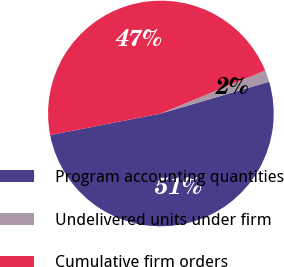<chart> <loc_0><loc_0><loc_500><loc_500><pie_chart><fcel>Program accounting quantities<fcel>Undelivered units under firm<fcel>Cumulative firm orders<nl><fcel>51.48%<fcel>1.68%<fcel>46.85%<nl></chart> 